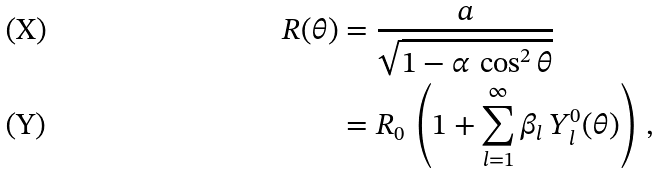Convert formula to latex. <formula><loc_0><loc_0><loc_500><loc_500>R ( \theta ) & = \frac { a } { \sqrt { 1 - \alpha \, \cos ^ { 2 } \theta } } \\ & = R _ { 0 } \, \left ( 1 + \sum _ { l = 1 } ^ { \infty } \beta _ { l } \, Y _ { l } ^ { 0 } ( \theta ) \right ) \, ,</formula> 